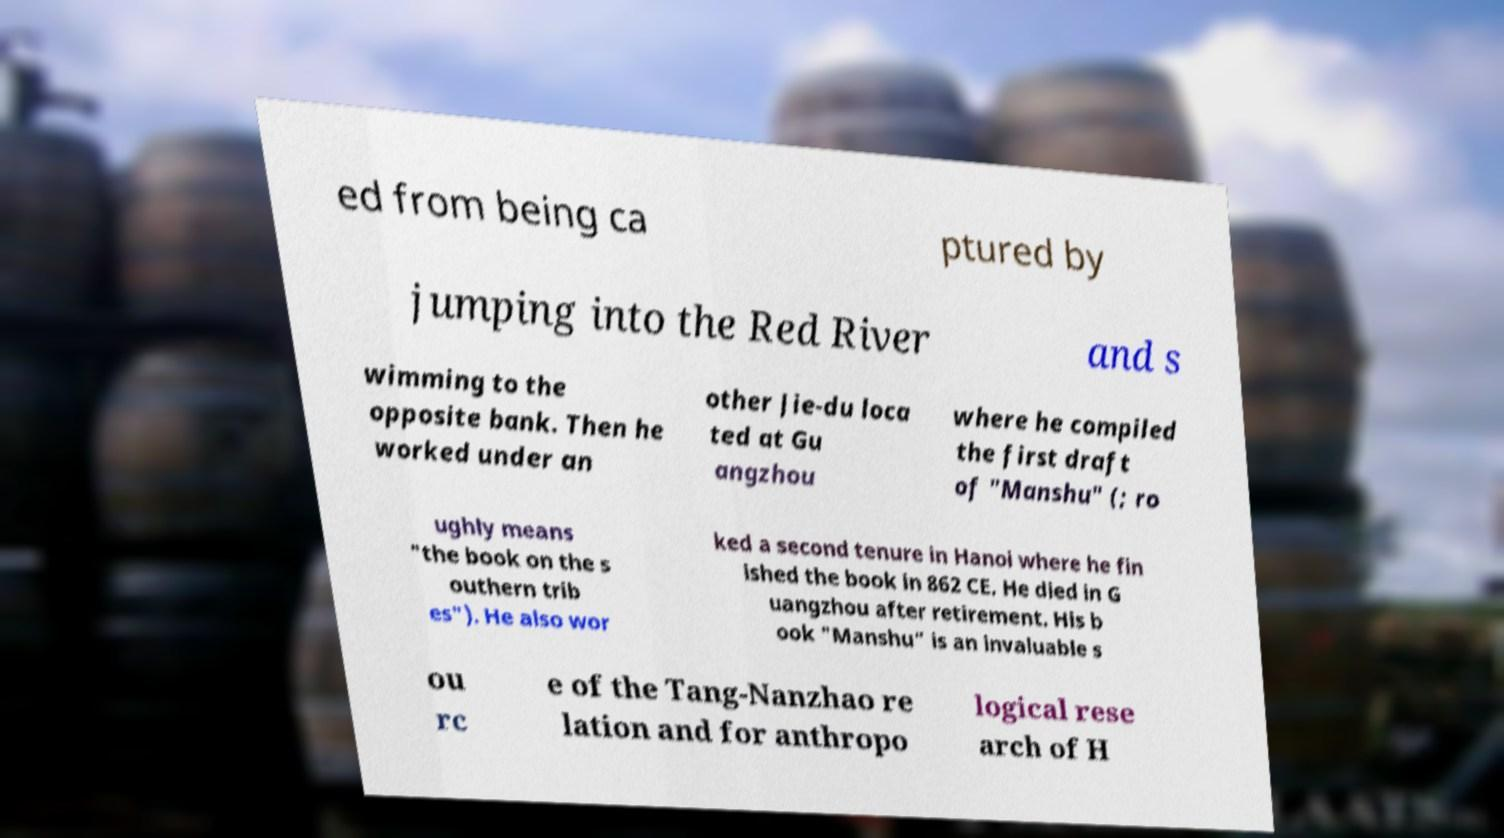Please identify and transcribe the text found in this image. ed from being ca ptured by jumping into the Red River and s wimming to the opposite bank. Then he worked under an other Jie-du loca ted at Gu angzhou where he compiled the first draft of "Manshu" (; ro ughly means "the book on the s outhern trib es"). He also wor ked a second tenure in Hanoi where he fin ished the book in 862 CE. He died in G uangzhou after retirement. His b ook "Manshu" is an invaluable s ou rc e of the Tang-Nanzhao re lation and for anthropo logical rese arch of H 